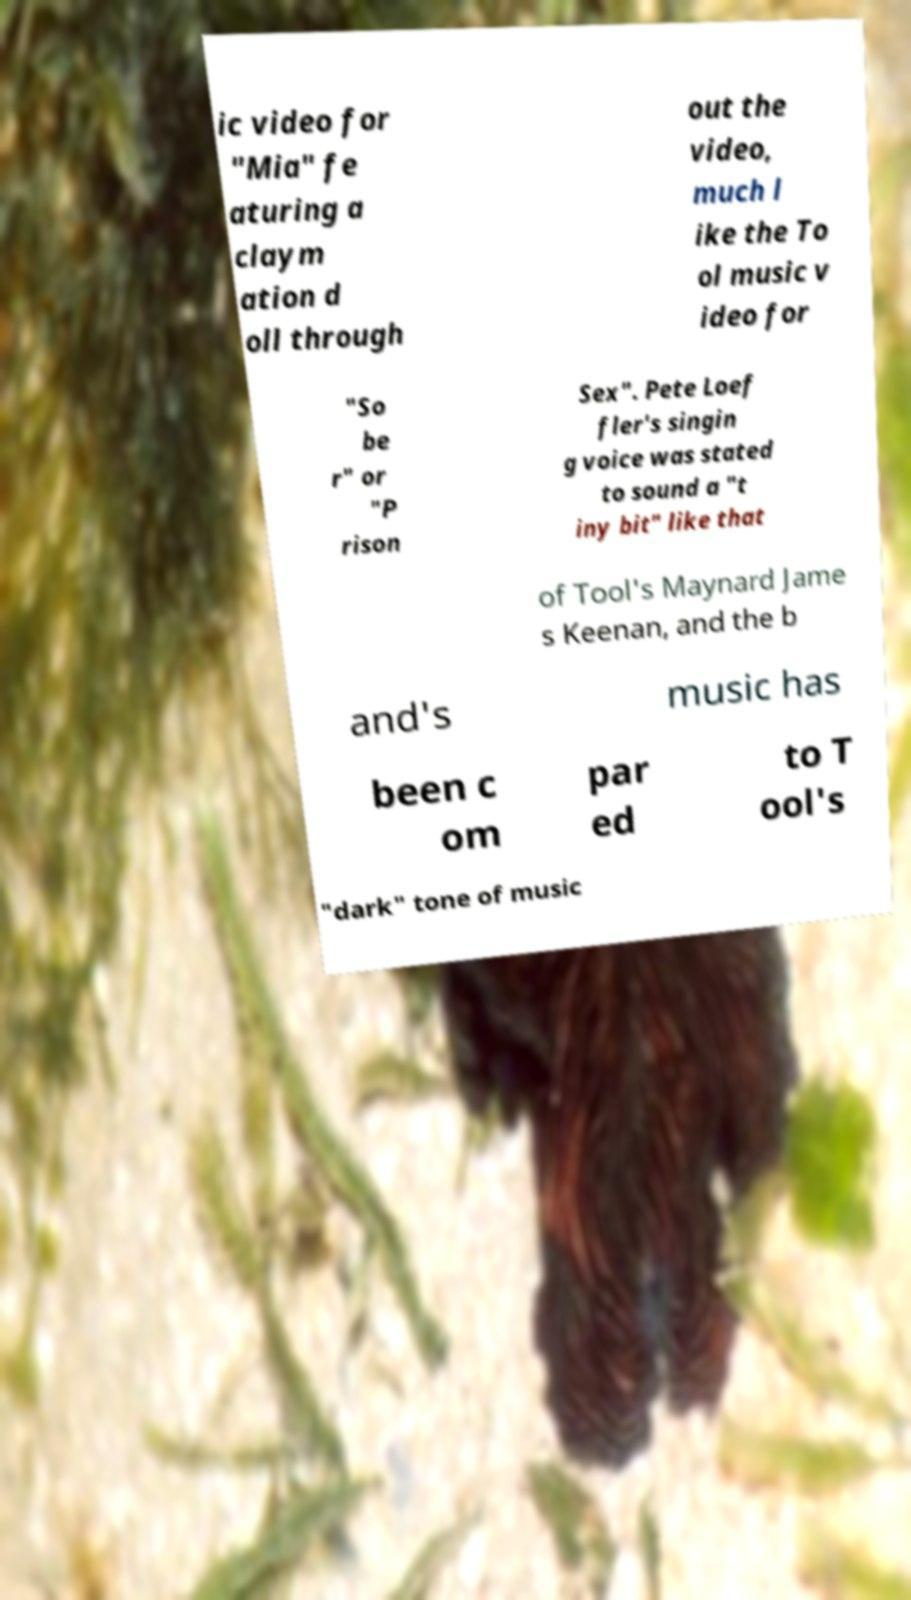Please read and relay the text visible in this image. What does it say? ic video for "Mia" fe aturing a claym ation d oll through out the video, much l ike the To ol music v ideo for "So be r" or "P rison Sex". Pete Loef fler's singin g voice was stated to sound a "t iny bit" like that of Tool's Maynard Jame s Keenan, and the b and's music has been c om par ed to T ool's "dark" tone of music 